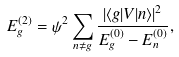Convert formula to latex. <formula><loc_0><loc_0><loc_500><loc_500>E _ { g } ^ { ( 2 ) } = \psi ^ { 2 } \sum _ { n \neq g } \frac { | \langle g | V | n \rangle | ^ { 2 } } { E _ { g } ^ { ( 0 ) } - E _ { n } ^ { ( 0 ) } } ,</formula> 